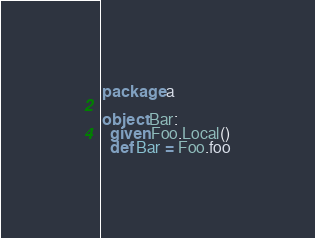<code> <loc_0><loc_0><loc_500><loc_500><_Scala_>package a

object Bar:
  given Foo.Local()
  def Bar = Foo.foo
</code> 